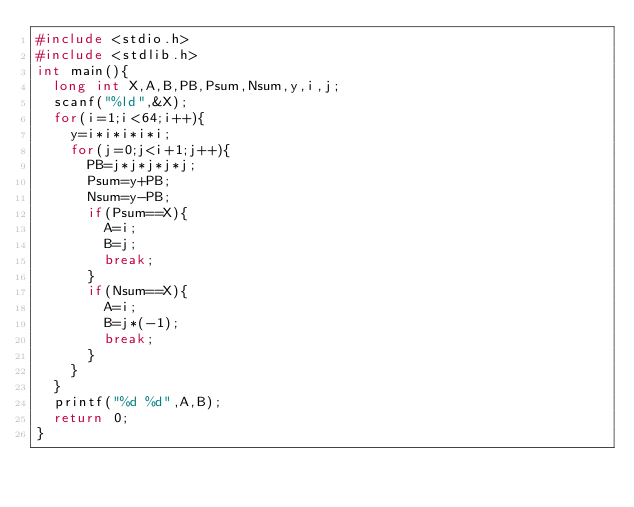Convert code to text. <code><loc_0><loc_0><loc_500><loc_500><_C_>#include <stdio.h>
#include <stdlib.h>
int main(){
  long int X,A,B,PB,Psum,Nsum,y,i,j;
  scanf("%ld",&X);
  for(i=1;i<64;i++){
    y=i*i*i*i*i;
    for(j=0;j<i+1;j++){
      PB=j*j*j*j*j;
      Psum=y+PB;
      Nsum=y-PB;
      if(Psum==X){
        A=i;
        B=j;
        break;
      }
      if(Nsum==X){
        A=i;
        B=j*(-1);
        break;
      }
    }
  }
  printf("%d %d",A,B);
  return 0;
}</code> 